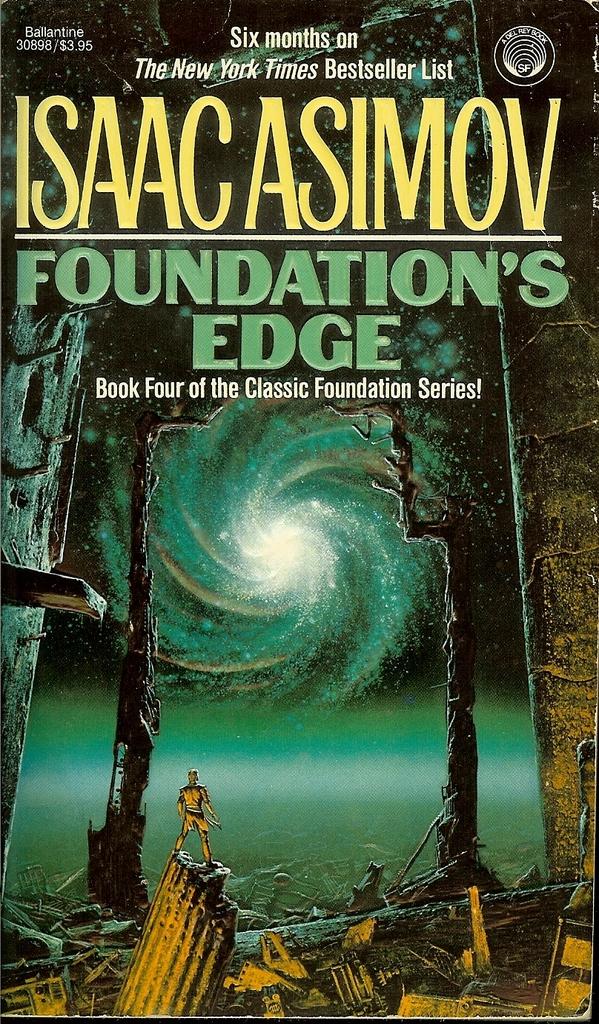How long did the book stay on the new york times bestseller list?
Give a very brief answer. Six months. Who is the author of the work?
Provide a succinct answer. Isaac asimov. 